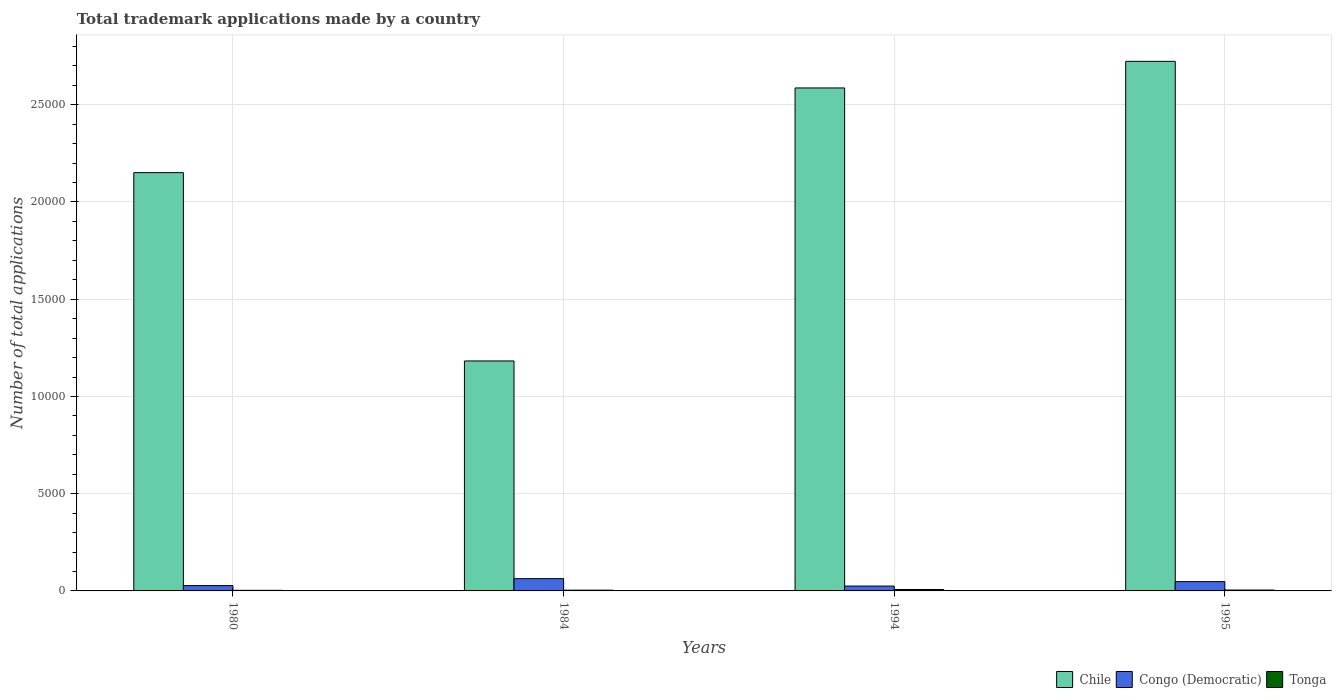How many groups of bars are there?
Keep it short and to the point. 4. Are the number of bars per tick equal to the number of legend labels?
Offer a very short reply. Yes. Are the number of bars on each tick of the X-axis equal?
Provide a succinct answer. Yes. How many bars are there on the 4th tick from the right?
Offer a very short reply. 3. In how many cases, is the number of bars for a given year not equal to the number of legend labels?
Ensure brevity in your answer.  0. What is the number of applications made by in Congo (Democratic) in 1984?
Your answer should be very brief. 631. Across all years, what is the maximum number of applications made by in Tonga?
Offer a terse response. 73. Across all years, what is the minimum number of applications made by in Chile?
Keep it short and to the point. 1.18e+04. In which year was the number of applications made by in Tonga maximum?
Keep it short and to the point. 1994. In which year was the number of applications made by in Chile minimum?
Make the answer very short. 1984. What is the total number of applications made by in Congo (Democratic) in the graph?
Your response must be concise. 1633. What is the difference between the number of applications made by in Chile in 1994 and that in 1995?
Provide a succinct answer. -1367. What is the difference between the number of applications made by in Chile in 1994 and the number of applications made by in Congo (Democratic) in 1984?
Provide a short and direct response. 2.52e+04. What is the average number of applications made by in Congo (Democratic) per year?
Give a very brief answer. 408.25. In the year 1994, what is the difference between the number of applications made by in Chile and number of applications made by in Tonga?
Offer a terse response. 2.58e+04. In how many years, is the number of applications made by in Chile greater than 2000?
Provide a succinct answer. 4. What is the ratio of the number of applications made by in Tonga in 1980 to that in 1984?
Your response must be concise. 0.79. Is the number of applications made by in Congo (Democratic) in 1980 less than that in 1995?
Your response must be concise. Yes. Is the difference between the number of applications made by in Chile in 1994 and 1995 greater than the difference between the number of applications made by in Tonga in 1994 and 1995?
Make the answer very short. No. What is the difference between the highest and the second highest number of applications made by in Tonga?
Give a very brief answer. 28. What is the difference between the highest and the lowest number of applications made by in Congo (Democratic)?
Provide a succinct answer. 381. What does the 3rd bar from the left in 1984 represents?
Offer a terse response. Tonga. Is it the case that in every year, the sum of the number of applications made by in Tonga and number of applications made by in Congo (Democratic) is greater than the number of applications made by in Chile?
Offer a terse response. No. Are all the bars in the graph horizontal?
Give a very brief answer. No. What is the difference between two consecutive major ticks on the Y-axis?
Offer a terse response. 5000. Are the values on the major ticks of Y-axis written in scientific E-notation?
Offer a very short reply. No. Does the graph contain any zero values?
Make the answer very short. No. Does the graph contain grids?
Keep it short and to the point. Yes. What is the title of the graph?
Provide a succinct answer. Total trademark applications made by a country. What is the label or title of the Y-axis?
Make the answer very short. Number of total applications. What is the Number of total applications in Chile in 1980?
Your answer should be compact. 2.15e+04. What is the Number of total applications of Congo (Democratic) in 1980?
Your answer should be compact. 274. What is the Number of total applications in Chile in 1984?
Your answer should be compact. 1.18e+04. What is the Number of total applications of Congo (Democratic) in 1984?
Offer a terse response. 631. What is the Number of total applications of Tonga in 1984?
Your answer should be compact. 39. What is the Number of total applications of Chile in 1994?
Your response must be concise. 2.59e+04. What is the Number of total applications of Congo (Democratic) in 1994?
Your response must be concise. 250. What is the Number of total applications of Tonga in 1994?
Your answer should be very brief. 73. What is the Number of total applications of Chile in 1995?
Keep it short and to the point. 2.72e+04. What is the Number of total applications in Congo (Democratic) in 1995?
Give a very brief answer. 478. What is the Number of total applications in Tonga in 1995?
Your answer should be compact. 45. Across all years, what is the maximum Number of total applications of Chile?
Make the answer very short. 2.72e+04. Across all years, what is the maximum Number of total applications in Congo (Democratic)?
Your answer should be compact. 631. Across all years, what is the minimum Number of total applications in Chile?
Keep it short and to the point. 1.18e+04. Across all years, what is the minimum Number of total applications of Congo (Democratic)?
Keep it short and to the point. 250. What is the total Number of total applications of Chile in the graph?
Your response must be concise. 8.64e+04. What is the total Number of total applications in Congo (Democratic) in the graph?
Offer a very short reply. 1633. What is the total Number of total applications of Tonga in the graph?
Your response must be concise. 188. What is the difference between the Number of total applications in Chile in 1980 and that in 1984?
Ensure brevity in your answer.  9683. What is the difference between the Number of total applications of Congo (Democratic) in 1980 and that in 1984?
Keep it short and to the point. -357. What is the difference between the Number of total applications in Chile in 1980 and that in 1994?
Your response must be concise. -4355. What is the difference between the Number of total applications in Congo (Democratic) in 1980 and that in 1994?
Give a very brief answer. 24. What is the difference between the Number of total applications of Tonga in 1980 and that in 1994?
Make the answer very short. -42. What is the difference between the Number of total applications in Chile in 1980 and that in 1995?
Your response must be concise. -5722. What is the difference between the Number of total applications of Congo (Democratic) in 1980 and that in 1995?
Your answer should be very brief. -204. What is the difference between the Number of total applications of Tonga in 1980 and that in 1995?
Offer a terse response. -14. What is the difference between the Number of total applications in Chile in 1984 and that in 1994?
Keep it short and to the point. -1.40e+04. What is the difference between the Number of total applications of Congo (Democratic) in 1984 and that in 1994?
Provide a short and direct response. 381. What is the difference between the Number of total applications in Tonga in 1984 and that in 1994?
Give a very brief answer. -34. What is the difference between the Number of total applications in Chile in 1984 and that in 1995?
Provide a short and direct response. -1.54e+04. What is the difference between the Number of total applications of Congo (Democratic) in 1984 and that in 1995?
Keep it short and to the point. 153. What is the difference between the Number of total applications in Tonga in 1984 and that in 1995?
Make the answer very short. -6. What is the difference between the Number of total applications of Chile in 1994 and that in 1995?
Provide a short and direct response. -1367. What is the difference between the Number of total applications in Congo (Democratic) in 1994 and that in 1995?
Your response must be concise. -228. What is the difference between the Number of total applications in Chile in 1980 and the Number of total applications in Congo (Democratic) in 1984?
Provide a short and direct response. 2.09e+04. What is the difference between the Number of total applications in Chile in 1980 and the Number of total applications in Tonga in 1984?
Your response must be concise. 2.15e+04. What is the difference between the Number of total applications of Congo (Democratic) in 1980 and the Number of total applications of Tonga in 1984?
Offer a very short reply. 235. What is the difference between the Number of total applications of Chile in 1980 and the Number of total applications of Congo (Democratic) in 1994?
Give a very brief answer. 2.13e+04. What is the difference between the Number of total applications in Chile in 1980 and the Number of total applications in Tonga in 1994?
Give a very brief answer. 2.14e+04. What is the difference between the Number of total applications of Congo (Democratic) in 1980 and the Number of total applications of Tonga in 1994?
Keep it short and to the point. 201. What is the difference between the Number of total applications of Chile in 1980 and the Number of total applications of Congo (Democratic) in 1995?
Give a very brief answer. 2.10e+04. What is the difference between the Number of total applications of Chile in 1980 and the Number of total applications of Tonga in 1995?
Your answer should be compact. 2.15e+04. What is the difference between the Number of total applications of Congo (Democratic) in 1980 and the Number of total applications of Tonga in 1995?
Offer a very short reply. 229. What is the difference between the Number of total applications of Chile in 1984 and the Number of total applications of Congo (Democratic) in 1994?
Your answer should be very brief. 1.16e+04. What is the difference between the Number of total applications of Chile in 1984 and the Number of total applications of Tonga in 1994?
Provide a short and direct response. 1.18e+04. What is the difference between the Number of total applications in Congo (Democratic) in 1984 and the Number of total applications in Tonga in 1994?
Your answer should be compact. 558. What is the difference between the Number of total applications of Chile in 1984 and the Number of total applications of Congo (Democratic) in 1995?
Ensure brevity in your answer.  1.13e+04. What is the difference between the Number of total applications in Chile in 1984 and the Number of total applications in Tonga in 1995?
Offer a very short reply. 1.18e+04. What is the difference between the Number of total applications in Congo (Democratic) in 1984 and the Number of total applications in Tonga in 1995?
Give a very brief answer. 586. What is the difference between the Number of total applications in Chile in 1994 and the Number of total applications in Congo (Democratic) in 1995?
Offer a terse response. 2.54e+04. What is the difference between the Number of total applications of Chile in 1994 and the Number of total applications of Tonga in 1995?
Your response must be concise. 2.58e+04. What is the difference between the Number of total applications of Congo (Democratic) in 1994 and the Number of total applications of Tonga in 1995?
Provide a succinct answer. 205. What is the average Number of total applications of Chile per year?
Offer a terse response. 2.16e+04. What is the average Number of total applications of Congo (Democratic) per year?
Your answer should be very brief. 408.25. What is the average Number of total applications of Tonga per year?
Your answer should be very brief. 47. In the year 1980, what is the difference between the Number of total applications in Chile and Number of total applications in Congo (Democratic)?
Your answer should be very brief. 2.12e+04. In the year 1980, what is the difference between the Number of total applications of Chile and Number of total applications of Tonga?
Provide a short and direct response. 2.15e+04. In the year 1980, what is the difference between the Number of total applications of Congo (Democratic) and Number of total applications of Tonga?
Provide a succinct answer. 243. In the year 1984, what is the difference between the Number of total applications of Chile and Number of total applications of Congo (Democratic)?
Offer a terse response. 1.12e+04. In the year 1984, what is the difference between the Number of total applications of Chile and Number of total applications of Tonga?
Make the answer very short. 1.18e+04. In the year 1984, what is the difference between the Number of total applications of Congo (Democratic) and Number of total applications of Tonga?
Make the answer very short. 592. In the year 1994, what is the difference between the Number of total applications of Chile and Number of total applications of Congo (Democratic)?
Ensure brevity in your answer.  2.56e+04. In the year 1994, what is the difference between the Number of total applications in Chile and Number of total applications in Tonga?
Provide a succinct answer. 2.58e+04. In the year 1994, what is the difference between the Number of total applications of Congo (Democratic) and Number of total applications of Tonga?
Provide a succinct answer. 177. In the year 1995, what is the difference between the Number of total applications of Chile and Number of total applications of Congo (Democratic)?
Your answer should be compact. 2.68e+04. In the year 1995, what is the difference between the Number of total applications in Chile and Number of total applications in Tonga?
Your answer should be very brief. 2.72e+04. In the year 1995, what is the difference between the Number of total applications in Congo (Democratic) and Number of total applications in Tonga?
Make the answer very short. 433. What is the ratio of the Number of total applications of Chile in 1980 to that in 1984?
Provide a short and direct response. 1.82. What is the ratio of the Number of total applications in Congo (Democratic) in 1980 to that in 1984?
Give a very brief answer. 0.43. What is the ratio of the Number of total applications in Tonga in 1980 to that in 1984?
Make the answer very short. 0.79. What is the ratio of the Number of total applications of Chile in 1980 to that in 1994?
Offer a very short reply. 0.83. What is the ratio of the Number of total applications in Congo (Democratic) in 1980 to that in 1994?
Make the answer very short. 1.1. What is the ratio of the Number of total applications of Tonga in 1980 to that in 1994?
Your answer should be compact. 0.42. What is the ratio of the Number of total applications in Chile in 1980 to that in 1995?
Offer a terse response. 0.79. What is the ratio of the Number of total applications of Congo (Democratic) in 1980 to that in 1995?
Ensure brevity in your answer.  0.57. What is the ratio of the Number of total applications in Tonga in 1980 to that in 1995?
Your response must be concise. 0.69. What is the ratio of the Number of total applications in Chile in 1984 to that in 1994?
Offer a terse response. 0.46. What is the ratio of the Number of total applications in Congo (Democratic) in 1984 to that in 1994?
Make the answer very short. 2.52. What is the ratio of the Number of total applications in Tonga in 1984 to that in 1994?
Ensure brevity in your answer.  0.53. What is the ratio of the Number of total applications in Chile in 1984 to that in 1995?
Your response must be concise. 0.43. What is the ratio of the Number of total applications in Congo (Democratic) in 1984 to that in 1995?
Ensure brevity in your answer.  1.32. What is the ratio of the Number of total applications in Tonga in 1984 to that in 1995?
Your response must be concise. 0.87. What is the ratio of the Number of total applications of Chile in 1994 to that in 1995?
Make the answer very short. 0.95. What is the ratio of the Number of total applications in Congo (Democratic) in 1994 to that in 1995?
Offer a very short reply. 0.52. What is the ratio of the Number of total applications in Tonga in 1994 to that in 1995?
Provide a short and direct response. 1.62. What is the difference between the highest and the second highest Number of total applications in Chile?
Your response must be concise. 1367. What is the difference between the highest and the second highest Number of total applications of Congo (Democratic)?
Your answer should be compact. 153. What is the difference between the highest and the lowest Number of total applications in Chile?
Your answer should be compact. 1.54e+04. What is the difference between the highest and the lowest Number of total applications of Congo (Democratic)?
Provide a succinct answer. 381. What is the difference between the highest and the lowest Number of total applications of Tonga?
Make the answer very short. 42. 